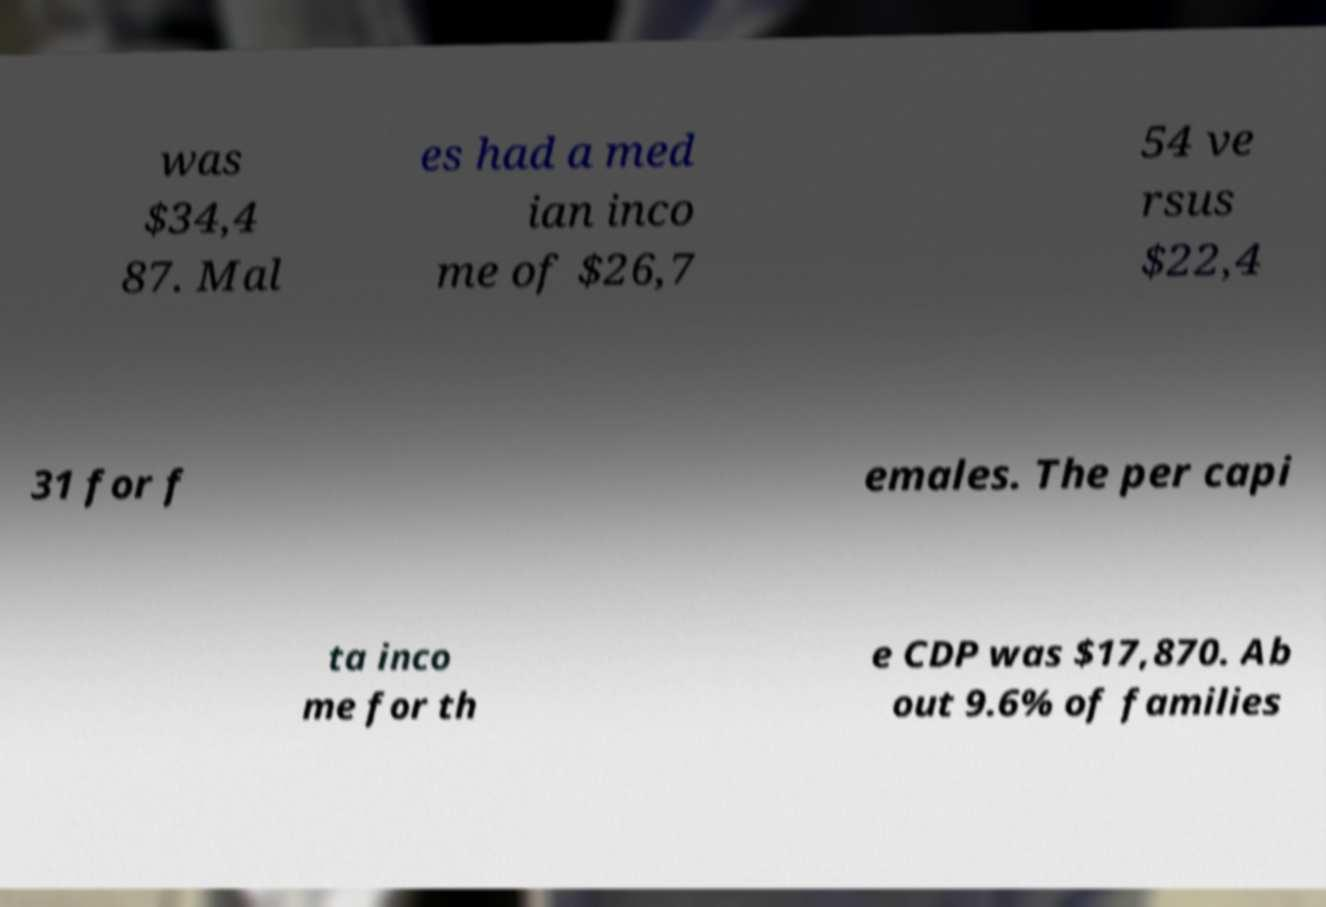I need the written content from this picture converted into text. Can you do that? was $34,4 87. Mal es had a med ian inco me of $26,7 54 ve rsus $22,4 31 for f emales. The per capi ta inco me for th e CDP was $17,870. Ab out 9.6% of families 